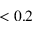Convert formula to latex. <formula><loc_0><loc_0><loc_500><loc_500>< 0 . 2</formula> 